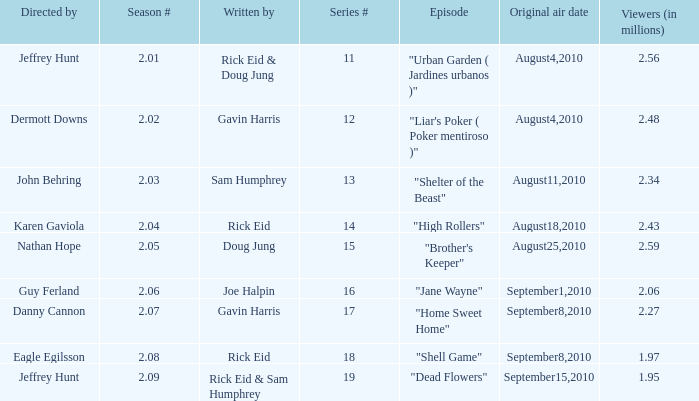If the season number is 2.08, who was the episode written by? Rick Eid. 